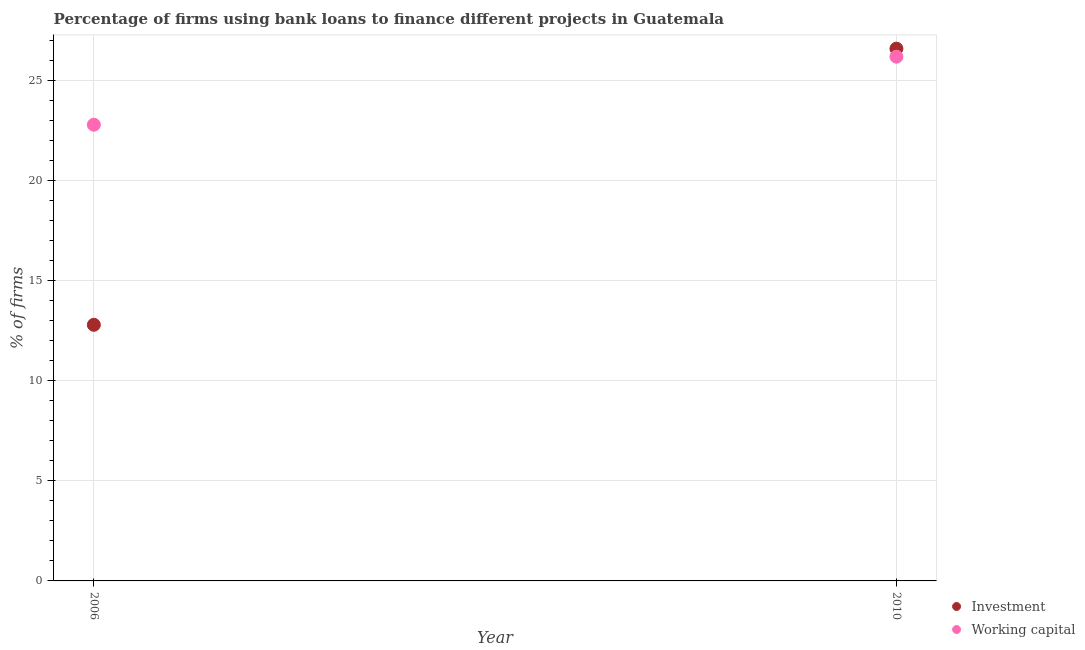How many different coloured dotlines are there?
Offer a terse response. 2. Is the number of dotlines equal to the number of legend labels?
Make the answer very short. Yes. Across all years, what is the maximum percentage of firms using banks to finance investment?
Keep it short and to the point. 26.6. Across all years, what is the minimum percentage of firms using banks to finance working capital?
Offer a terse response. 22.8. What is the difference between the percentage of firms using banks to finance investment in 2010 and the percentage of firms using banks to finance working capital in 2006?
Give a very brief answer. 3.8. In the year 2010, what is the difference between the percentage of firms using banks to finance investment and percentage of firms using banks to finance working capital?
Provide a succinct answer. 0.4. What is the ratio of the percentage of firms using banks to finance working capital in 2006 to that in 2010?
Your answer should be very brief. 0.87. Is the percentage of firms using banks to finance investment in 2006 less than that in 2010?
Your response must be concise. Yes. In how many years, is the percentage of firms using banks to finance investment greater than the average percentage of firms using banks to finance investment taken over all years?
Provide a short and direct response. 1. Is the percentage of firms using banks to finance investment strictly greater than the percentage of firms using banks to finance working capital over the years?
Offer a very short reply. No. Is the percentage of firms using banks to finance investment strictly less than the percentage of firms using banks to finance working capital over the years?
Keep it short and to the point. No. How many years are there in the graph?
Keep it short and to the point. 2. What is the difference between two consecutive major ticks on the Y-axis?
Provide a short and direct response. 5. Are the values on the major ticks of Y-axis written in scientific E-notation?
Make the answer very short. No. Does the graph contain grids?
Your response must be concise. Yes. What is the title of the graph?
Your answer should be compact. Percentage of firms using bank loans to finance different projects in Guatemala. Does "ODA received" appear as one of the legend labels in the graph?
Offer a terse response. No. What is the label or title of the X-axis?
Ensure brevity in your answer.  Year. What is the label or title of the Y-axis?
Offer a very short reply. % of firms. What is the % of firms in Working capital in 2006?
Give a very brief answer. 22.8. What is the % of firms in Investment in 2010?
Keep it short and to the point. 26.6. What is the % of firms in Working capital in 2010?
Provide a succinct answer. 26.2. Across all years, what is the maximum % of firms of Investment?
Provide a succinct answer. 26.6. Across all years, what is the maximum % of firms of Working capital?
Offer a terse response. 26.2. Across all years, what is the minimum % of firms of Working capital?
Offer a very short reply. 22.8. What is the total % of firms of Investment in the graph?
Your answer should be very brief. 39.4. What is the difference between the % of firms in Investment in 2006 and that in 2010?
Your response must be concise. -13.8. What is the difference between the % of firms of Investment in 2006 and the % of firms of Working capital in 2010?
Offer a very short reply. -13.4. What is the average % of firms of Working capital per year?
Your answer should be compact. 24.5. What is the ratio of the % of firms in Investment in 2006 to that in 2010?
Your answer should be compact. 0.48. What is the ratio of the % of firms in Working capital in 2006 to that in 2010?
Provide a short and direct response. 0.87. What is the difference between the highest and the second highest % of firms of Working capital?
Provide a succinct answer. 3.4. What is the difference between the highest and the lowest % of firms of Investment?
Provide a short and direct response. 13.8. 